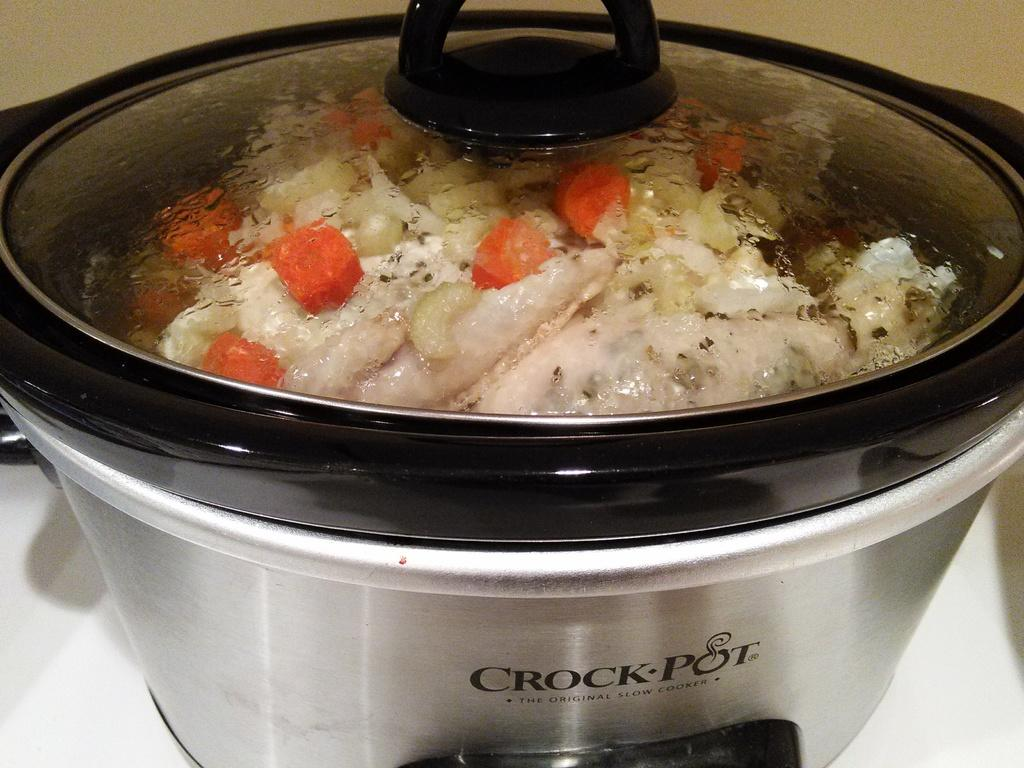What type of cooking appliance is in the image? There is an electric cooker in the image. What is the electric cooker placed on? The electric cooker is on a white platform. Is there any text or writing on the electric cooker? Yes, there is writing on the electric cooker. What can be seen through the glass lid of the cooker? Food is visible through the glass lid of the cooker. What type of cactus is growing on the neck of the person in the image? There is no person or cactus present in the image; it features an electric cooker on a white platform. 